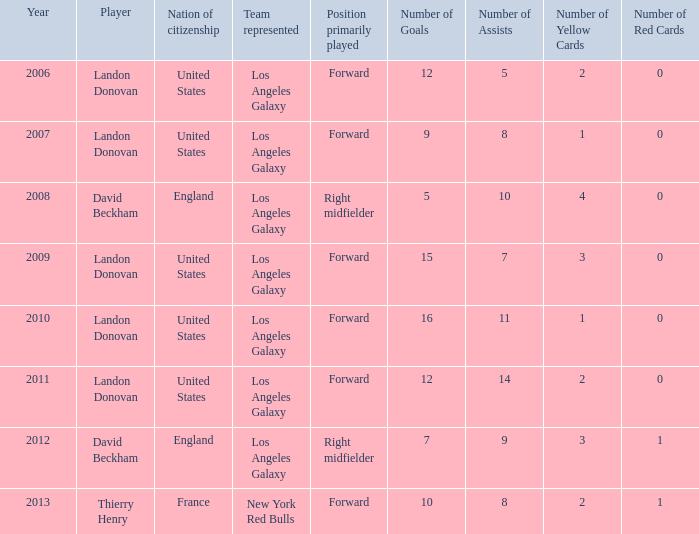What is the sum of all the years that Landon Donovan won the ESPY award? 5.0. 